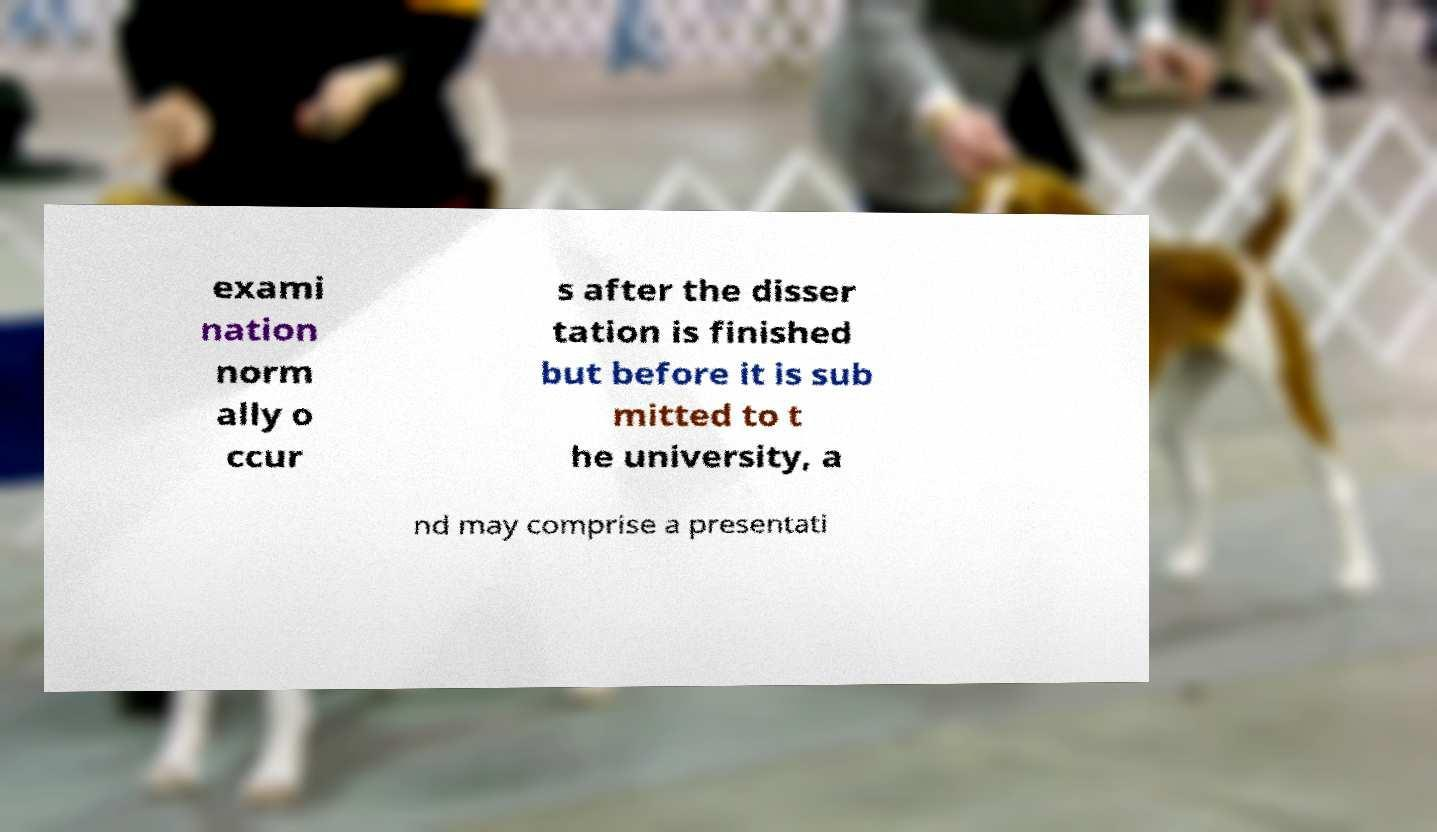Can you accurately transcribe the text from the provided image for me? exami nation norm ally o ccur s after the disser tation is finished but before it is sub mitted to t he university, a nd may comprise a presentati 